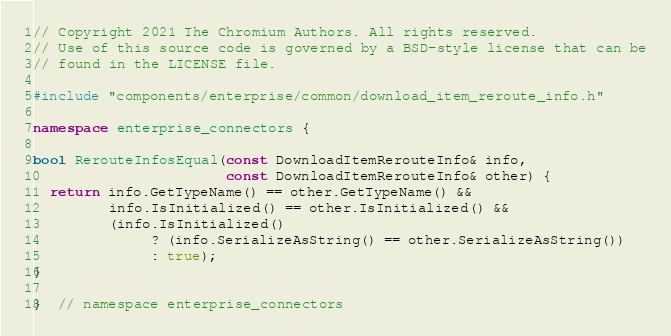Convert code to text. <code><loc_0><loc_0><loc_500><loc_500><_C++_>// Copyright 2021 The Chromium Authors. All rights reserved.
// Use of this source code is governed by a BSD-style license that can be
// found in the LICENSE file.

#include "components/enterprise/common/download_item_reroute_info.h"

namespace enterprise_connectors {

bool RerouteInfosEqual(const DownloadItemRerouteInfo& info,
                       const DownloadItemRerouteInfo& other) {
  return info.GetTypeName() == other.GetTypeName() &&
         info.IsInitialized() == other.IsInitialized() &&
         (info.IsInitialized()
              ? (info.SerializeAsString() == other.SerializeAsString())
              : true);
}

}  // namespace enterprise_connectors
</code> 